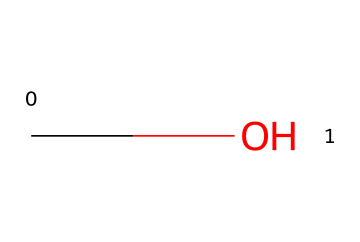What is the molecular formula of this chemical? The SMILES representation "CO" indicates one carbon atom (C) and one oxygen atom (O), together forming the molecular formula CH3OH.
Answer: CH3OH How many hydrogen atoms are present in methanol? The structure indicated by the SMILES "CO" has three hydrogen atoms bonded to the carbon atom, which confirms there are three hydrogen atoms in methanol.
Answer: 3 What type of functional group is present in methanol? The presence of a hydroxyl group (-OH) attached to the carbon in methanol signifies that it is an alcohol, which is characterized by having this functional group.
Answer: alcohol Is methanol polar or nonpolar? The hydroxyl group in methanol allows for a significant dipole moment, making it polar due to the unequal distribution of electron density between the oxygen and hydrogen atoms.
Answer: polar Can methanol act as a solvent for polar substances? Since methanol is polar, it can effectively dissolve many polar substances, similar to how water functions as a solvent, making it ideal for use in various chemical applications, including cement production.
Answer: yes What is the common use of methanol in the cement industry? Methanol is often used as a solvent in the formulation of certain types of cement additives, where it helps in dissolution and mixing processes, facilitating better chemical reactions.
Answer: solvent 